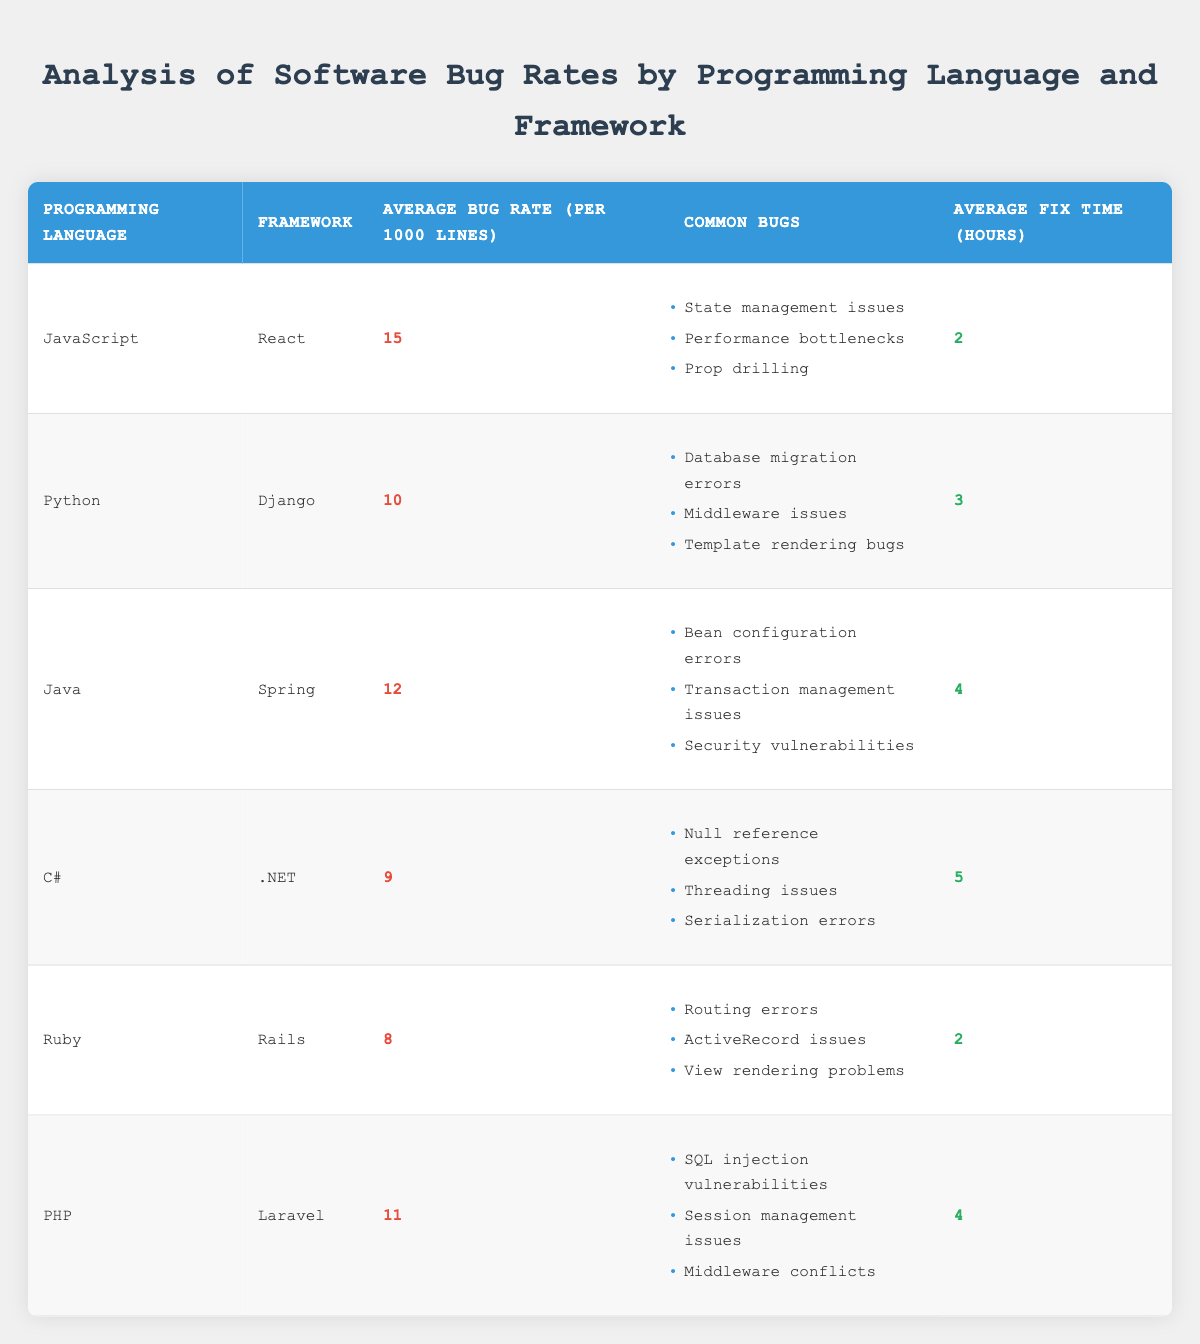What is the average bug rate for JavaScript using React? The table shows that the average bug rate for JavaScript using React is stated directly in the corresponding column, which is 15 bugs per 1000 lines of code.
Answer: 15 How many hours on average does it take to fix bugs in Ruby on Rails? Referring to the table, the average fix time for bugs in Ruby on Rails is provided in the last column, which is 2 hours.
Answer: 2 Which programming language has the highest average bug rate, and what is that rate? By examining the table, JavaScript has the highest average bug rate, which is 15 bugs per 1000 lines of code.
Answer: JavaScript, 15 Is the average bug rate for Python using Django higher than for Ruby using Rails? Looking at the respective average bug rates in the table, Python with Django has a bug rate of 10, while Ruby with Rails has a bug rate of 8. Since 10 is greater than 8, the answer is yes.
Answer: Yes What is the total average fix time for C# using .NET and Java using Spring combined? The average fix time for C# using .NET is 5 hours, and for Java using Spring, it is 4 hours. Summing these gives 5 + 4 = 9 hours.
Answer: 9 Are common bugs for PHP using Laravel related to performance issues? From the common bugs listed under PHP using Laravel, such as SQL injection vulnerabilities and session management issues, none directly mention performance issues. Thus, this statement is false.
Answer: No What is the difference in average bug rates between Java and PHP? The average bug rate for Java is 12, and for PHP, it is 11. The difference is calculated as 12 - 11 = 1.
Answer: 1 What percentage of common bugs listed for C# relates to threading issues? C# has three common bugs listed: null reference exceptions, threading issues, and serialization errors. Since only one out of three relates to threading, the percentage is (1/3) * 100 = 33.33%.
Answer: 33.33% Which framework has the lowest average bug rate, and what is that rate? Upon reviewing the table, Ruby using Rails has the lowest average bug rate of 8 bugs per 1000 lines of code.
Answer: Rails, 8 